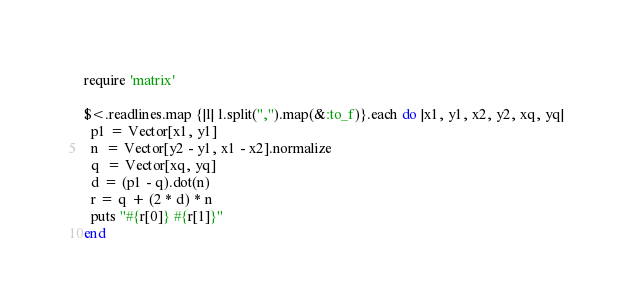<code> <loc_0><loc_0><loc_500><loc_500><_Ruby_>require 'matrix'

$<.readlines.map {|l| l.split(",").map(&:to_f)}.each do |x1, y1, x2, y2, xq, yq|
  p1 = Vector[x1, y1]
  n  = Vector[y2 - y1, x1 - x2].normalize
  q  = Vector[xq, yq]
  d = (p1 - q).dot(n)
  r = q + (2 * d) * n
  puts "#{r[0]} #{r[1]}"
end
</code> 